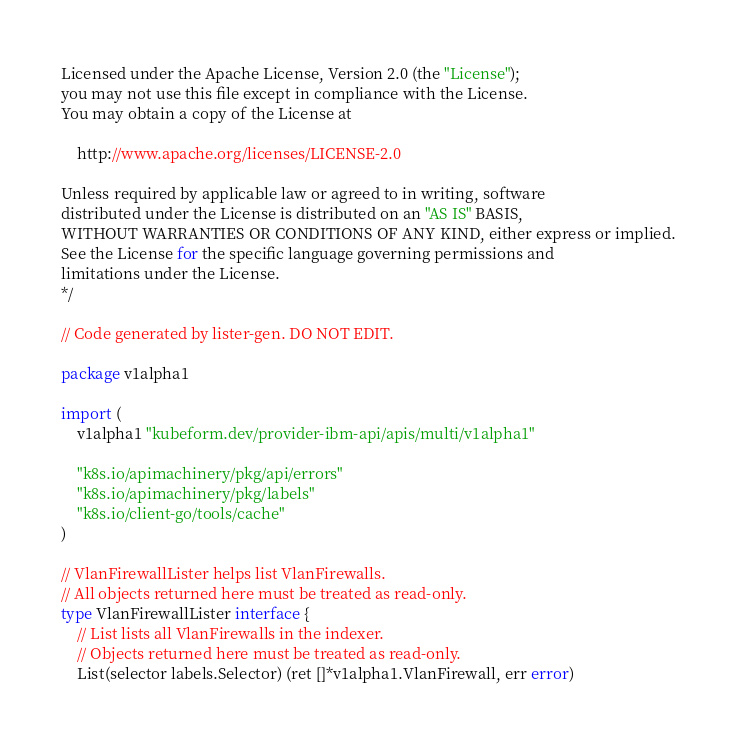Convert code to text. <code><loc_0><loc_0><loc_500><loc_500><_Go_>
Licensed under the Apache License, Version 2.0 (the "License");
you may not use this file except in compliance with the License.
You may obtain a copy of the License at

    http://www.apache.org/licenses/LICENSE-2.0

Unless required by applicable law or agreed to in writing, software
distributed under the License is distributed on an "AS IS" BASIS,
WITHOUT WARRANTIES OR CONDITIONS OF ANY KIND, either express or implied.
See the License for the specific language governing permissions and
limitations under the License.
*/

// Code generated by lister-gen. DO NOT EDIT.

package v1alpha1

import (
	v1alpha1 "kubeform.dev/provider-ibm-api/apis/multi/v1alpha1"

	"k8s.io/apimachinery/pkg/api/errors"
	"k8s.io/apimachinery/pkg/labels"
	"k8s.io/client-go/tools/cache"
)

// VlanFirewallLister helps list VlanFirewalls.
// All objects returned here must be treated as read-only.
type VlanFirewallLister interface {
	// List lists all VlanFirewalls in the indexer.
	// Objects returned here must be treated as read-only.
	List(selector labels.Selector) (ret []*v1alpha1.VlanFirewall, err error)</code> 